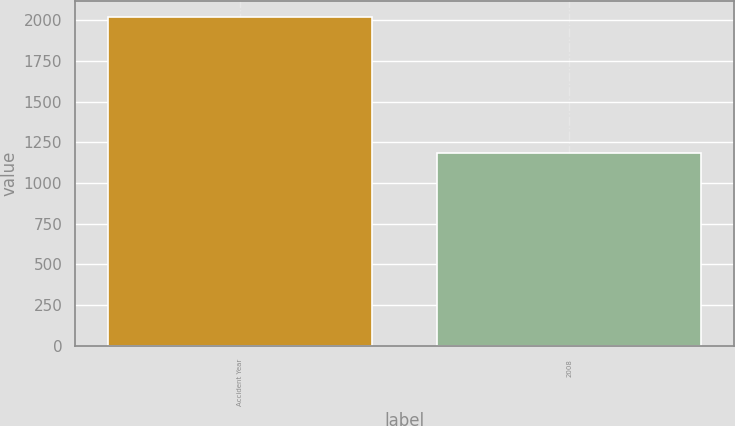Convert chart to OTSL. <chart><loc_0><loc_0><loc_500><loc_500><bar_chart><fcel>Accident Year<fcel>2008<nl><fcel>2017<fcel>1184<nl></chart> 